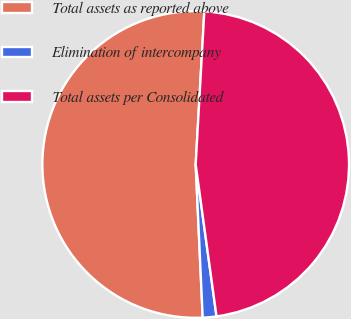Convert chart. <chart><loc_0><loc_0><loc_500><loc_500><pie_chart><fcel>Total assets as reported above<fcel>Elimination of intercompany<fcel>Total assets per Consolidated<nl><fcel>51.63%<fcel>1.44%<fcel>46.94%<nl></chart> 